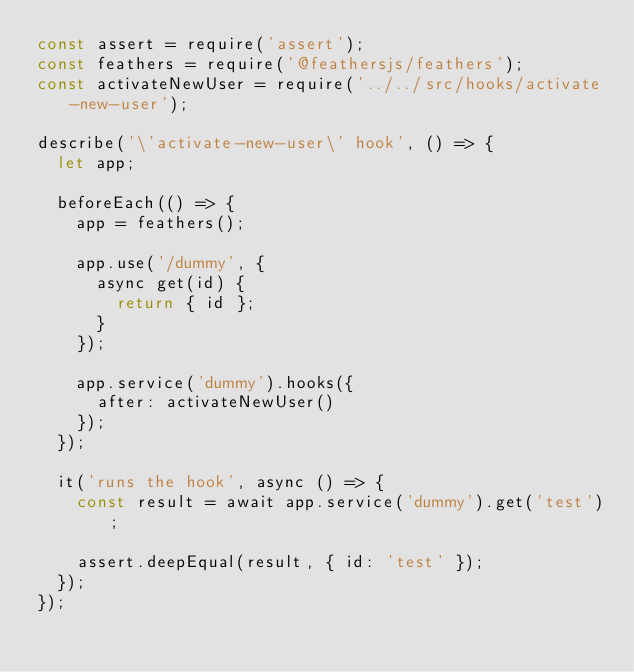<code> <loc_0><loc_0><loc_500><loc_500><_JavaScript_>const assert = require('assert');
const feathers = require('@feathersjs/feathers');
const activateNewUser = require('../../src/hooks/activate-new-user');

describe('\'activate-new-user\' hook', () => {
  let app;

  beforeEach(() => {
    app = feathers();

    app.use('/dummy', {
      async get(id) {
        return { id };
      }
    });

    app.service('dummy').hooks({
      after: activateNewUser()
    });
  });

  it('runs the hook', async () => {
    const result = await app.service('dummy').get('test');
    
    assert.deepEqual(result, { id: 'test' });
  });
});
</code> 